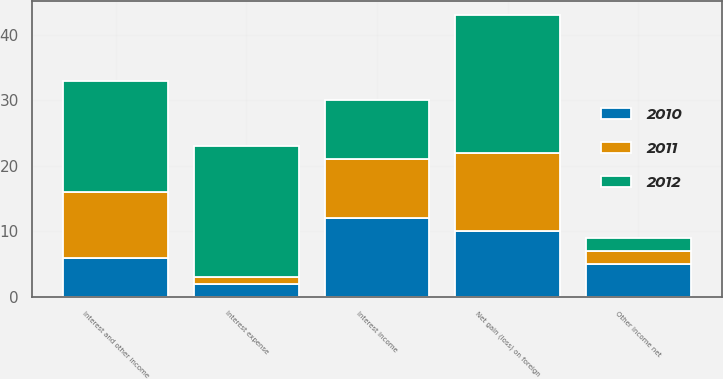<chart> <loc_0><loc_0><loc_500><loc_500><stacked_bar_chart><ecel><fcel>Interest expense<fcel>Interest income<fcel>Net gain (loss) on foreign<fcel>Other income net<fcel>Interest and other income<nl><fcel>2012<fcel>20<fcel>9<fcel>21<fcel>2<fcel>17<nl><fcel>2011<fcel>1<fcel>9<fcel>12<fcel>2<fcel>10<nl><fcel>2010<fcel>2<fcel>12<fcel>10<fcel>5<fcel>6<nl></chart> 